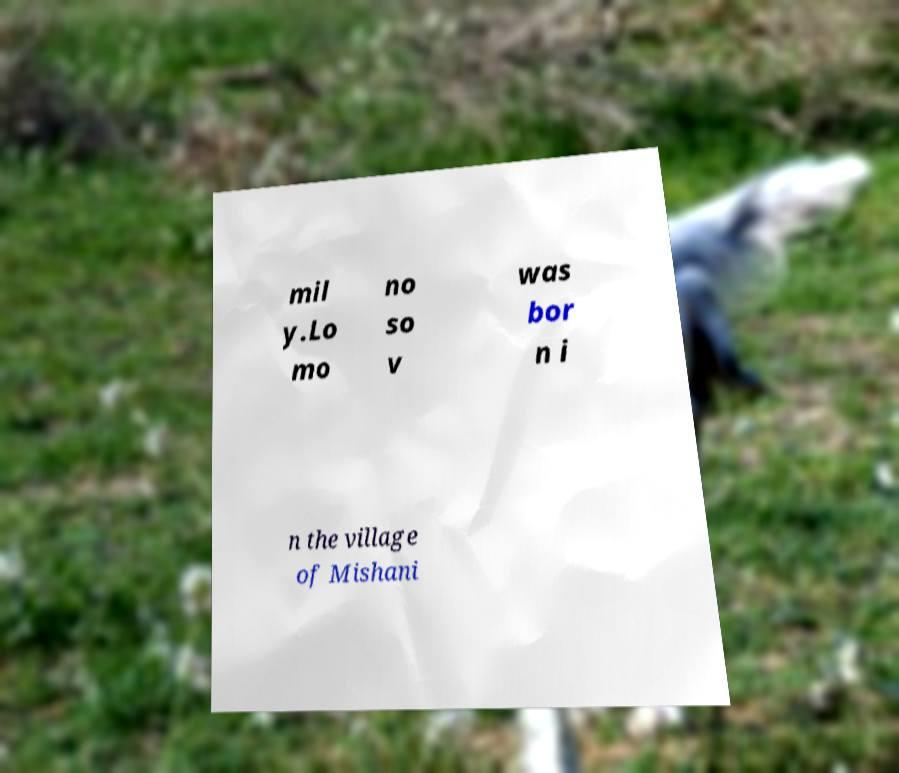Please read and relay the text visible in this image. What does it say? mil y.Lo mo no so v was bor n i n the village of Mishani 